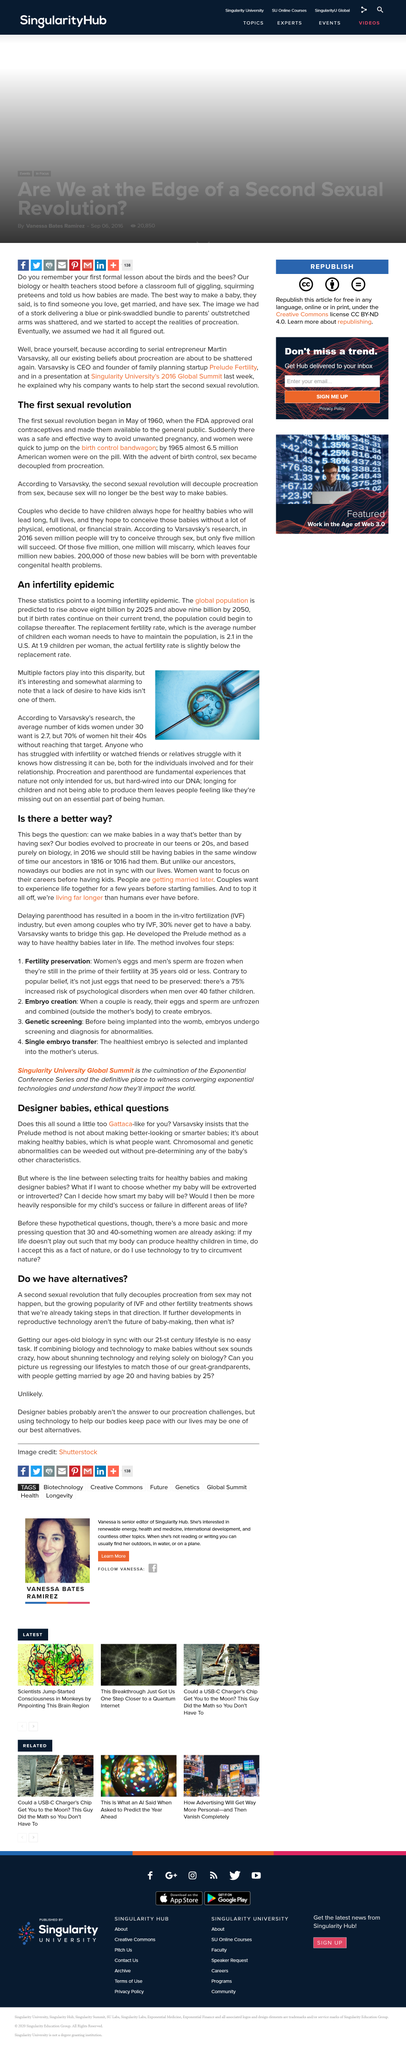Draw attention to some important aspects in this diagram. By the year 2050, it is projected that the global population will exceed 9 billion. The article refers to Varsavsky's research. According to a recent survey, 70% of women reach the age of 40 without having achieved their desired number of children. The first sexual revolution began in May 1960, marking a significant turning point in societal attitudes towards sex and sexuality. Women must have an average of 2.1 children in order to maintain the current population level. 